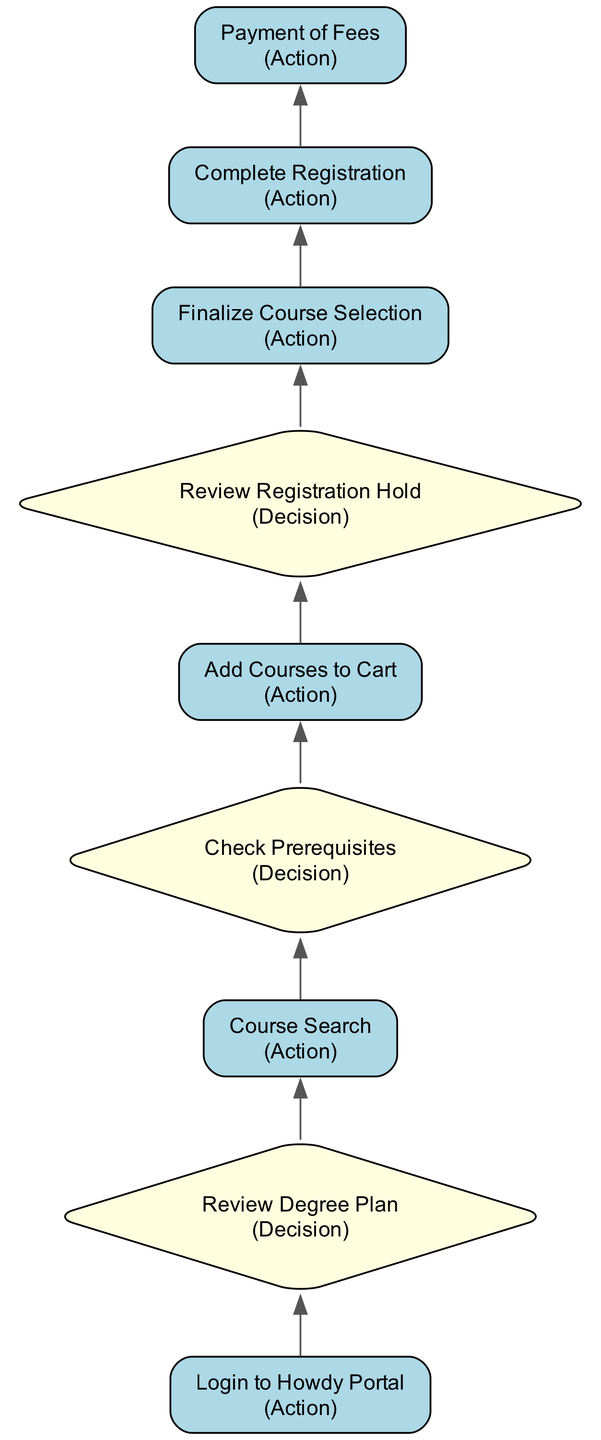What is the first action in the process? The first action in the flow chart is "Login to Howdy Portal," which is represented at the top of the diagram.
Answer: Login to Howdy Portal How many decision nodes are present in the diagram? By reviewing the diagram, we can see that there are three decision nodes: "Review Degree Plan," "Check Prerequisites," and "Review Registration Hold."
Answer: Three What follows the action "Course Search"? After the action "Course Search," the next step is the decision "Check Prerequisites." This indicates a process flow where searching for courses leads to verifying prerequisites.
Answer: Check Prerequisites What action comes before "Finalize Course Selection"? The action that comes before "Finalize Course Selection" is "Add Courses to Cart." This shows that adding courses is necessary before finalizing the choices.
Answer: Add Courses to Cart What is the last action in the process? The last action is "Payment of Fees," which is located at the bottom of the flow chart, indicating it is the final step to complete the registration process.
Answer: Payment of Fees Which decision checks if there are holds on the account? The decision that checks for holds on the account is "Review Registration Hold." This decision ensures that students do not have any blocks preventing them from registering.
Answer: Review Registration Hold What must be done immediately after "Finalize Course Selection"? Immediately after "Finalize Course Selection," the next step is "Complete Registration." This links the confirmation of course choices to the registration submission.
Answer: Complete Registration Which action can only occur if prerequisites are met? The action that can only occur if prerequisites are met is "Add Courses to Cart." This indicates that students need to verify eligibility before adding courses.
Answer: Add Courses to Cart 